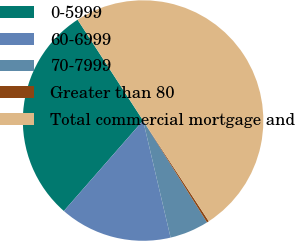Convert chart. <chart><loc_0><loc_0><loc_500><loc_500><pie_chart><fcel>0-5999<fcel>60-6999<fcel>70-7999<fcel>Greater than 80<fcel>Total commercial mortgage and<nl><fcel>29.39%<fcel>15.12%<fcel>5.25%<fcel>0.28%<fcel>49.97%<nl></chart> 